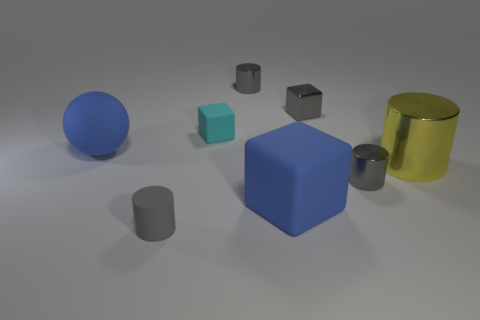Can you describe the lighting and shadows in the scene? The image has a central light source that casts soft shadows to the right of the objects. This indicates the illumination is coming from the left side of the frame. The shadows are gently diffused, suggesting an ambient light environment, which gives the scene a serene and calm atmosphere. 